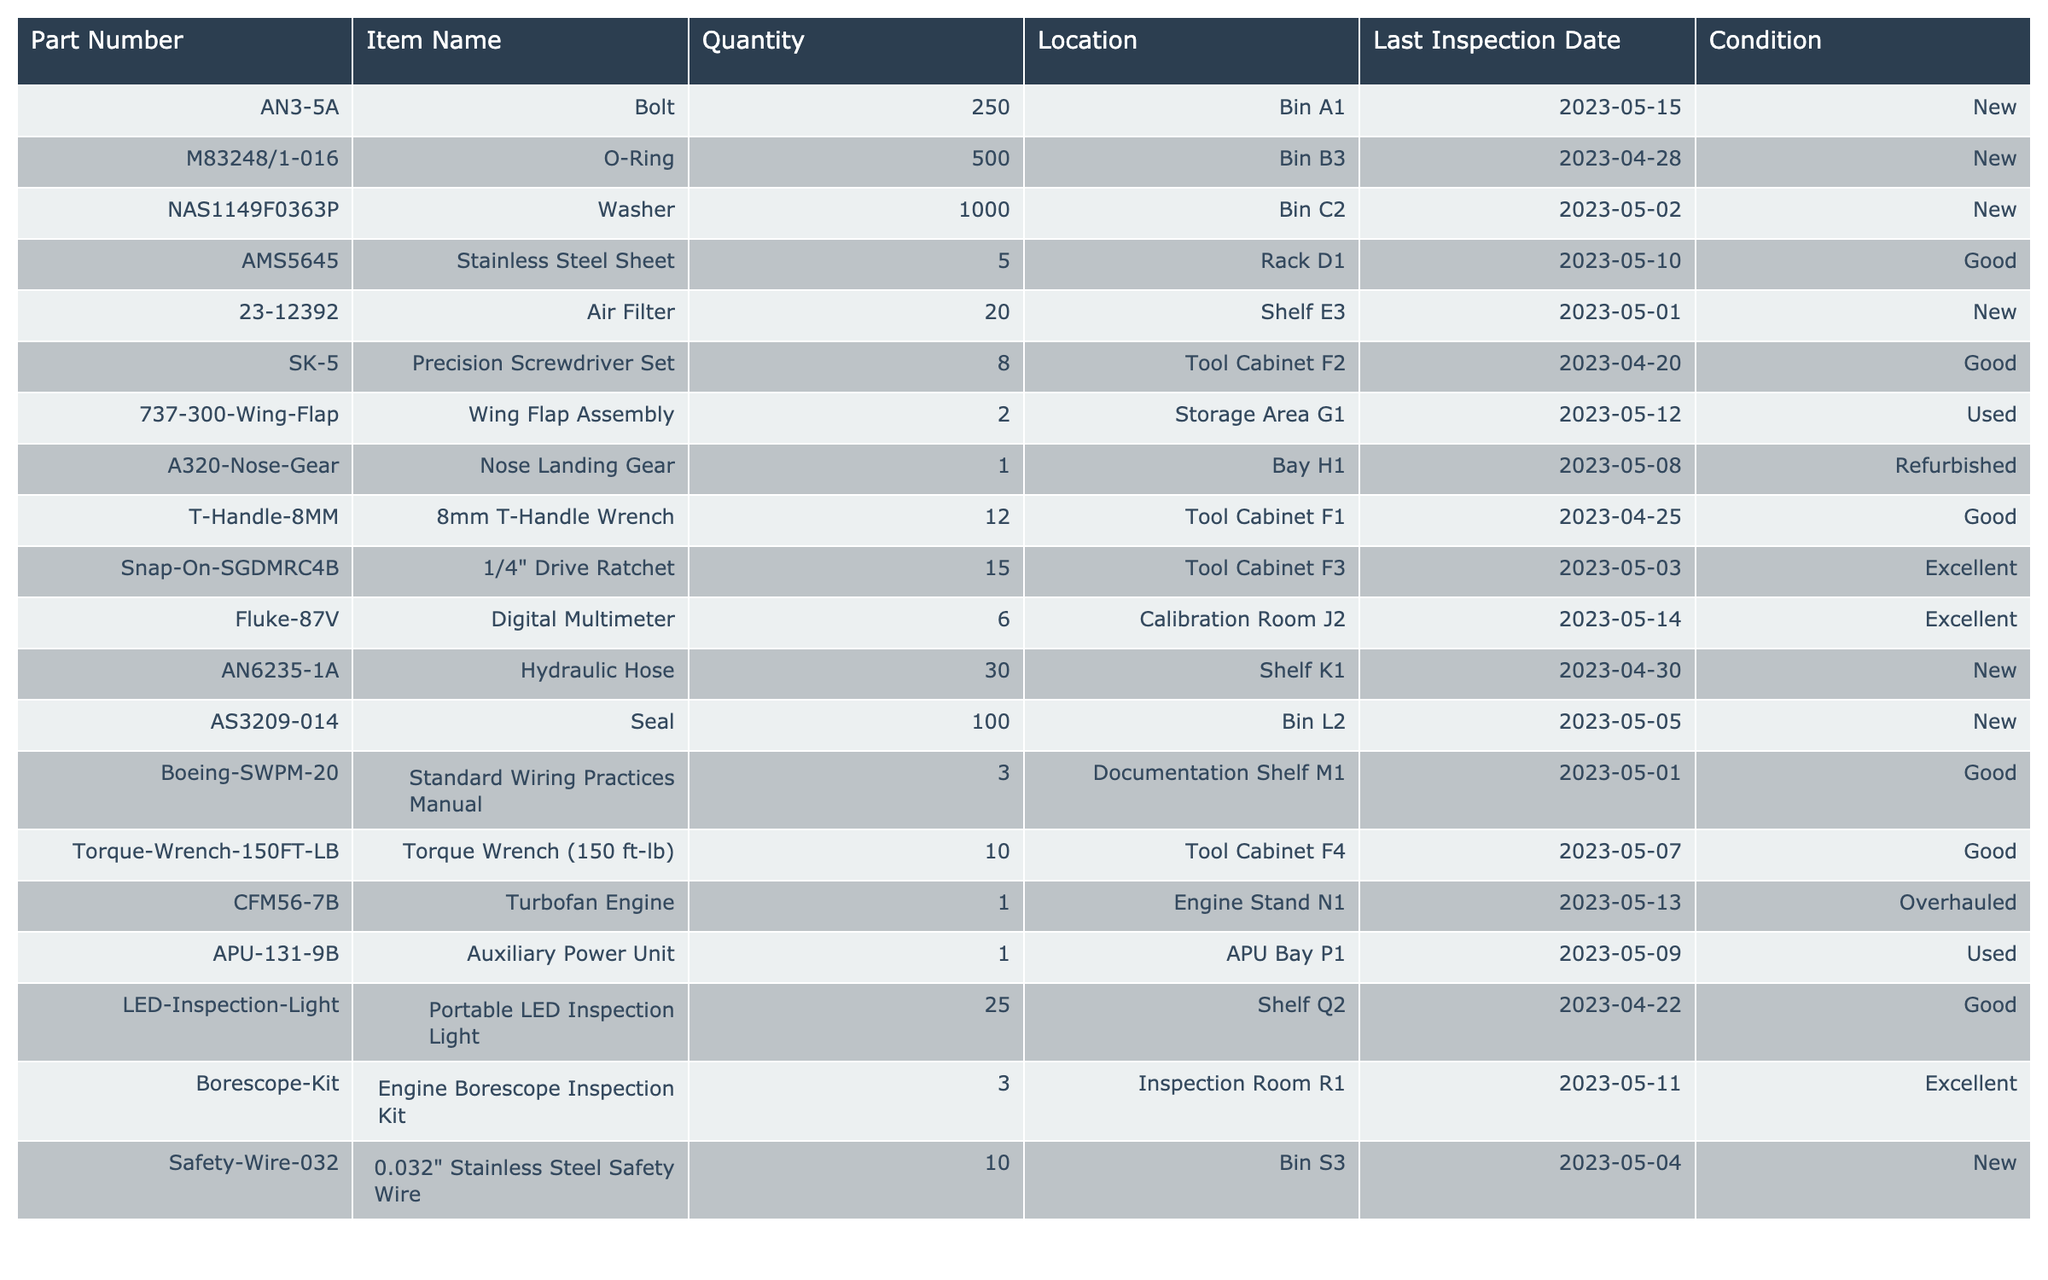What is the quantity of the O-Ring? Referring to the table, the O-Ring with the part number M83248/1-016 has a quantity listed as 500.
Answer: 500 Where is the Torquewrench located? The Torque Wrench (150 ft-lb) is located in the Tool Cabinet F4 according to the table.
Answer: Tool Cabinet F4 How many items are listed as 'New' in condition? By counting the items in the Condition column, five items are listed as 'New'; they are the Bolt, O-Ring, Air Filter, Hydraulic Hose, and Seal.
Answer: 5 What part has the last inspection date of May 1, 2023? The Air Filter (Part Number 23-12392) and the Standard Wiring Practices Manual (Part Number Boeing-SWPM-20) both have last inspection dates recorded on May 1, 2023.
Answer: Air Filter, Standard Wiring Practices Manual Which item has the least quantity? The item with the least quantity is the Stainless Steel Sheet, with only 5 units available.
Answer: 5 Is there an Auxiliary Power Unit listed as 'Used'? Yes, the Auxiliary Power Unit (Part Number APU-131-9B) is listed with a condition of 'Used.'
Answer: Yes What is the total quantity of items listed in the Tool Cabinets? The total quantity from the Tool Cabinets (F1, F2, F3, F4) is calculated as follows: 12 (8mm T-Handle Wrench) + 8 (Precision Screwdriver Set) + 15 (1/4" Drive Ratchet) + 10 (Torque Wrench) = 45.
Answer: 45 What is the difference in quantity between the Washer and the Wing Flap Assembly? The Washer has a quantity of 1000 and the Wing Flap Assembly has 2. The difference is calculated as 1000 - 2 = 998.
Answer: 998 How many items are stored at Shelf Q2? According to the table, there are 25 Portable LED Inspection Lights stored at Shelf Q2.
Answer: 25 Is there a part located in Bay H1, and what is its condition? Yes, the Nose Landing Gear (Part Number A320-Nose-Gear) is located in Bay H1, and its condition is listed as 'Refurbished.'
Answer: Yes, Refurbished How many items have a condition of 'Excellent' and what are they? The table shows 3 items listed as 'Excellent': the Digital Multimeter, the Engine Borescope Inspection Kit, and the 1/4" Drive Ratchet.
Answer: 3: Digital Multimeter, Engine Borescope Inspection Kit, 1/4" Drive Ratchet What is the count of parts that are either 'Used' or 'Refurbished'? There are 3 items fulfilling this criteria: the Wing Flap Assembly (Used), Nose Landing Gear (Refurbished), and Auxiliary Power Unit (Used). The total count is 3.
Answer: 3 